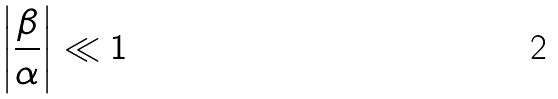<formula> <loc_0><loc_0><loc_500><loc_500>\left | \frac { \beta } { \alpha } \right | \ll 1</formula> 